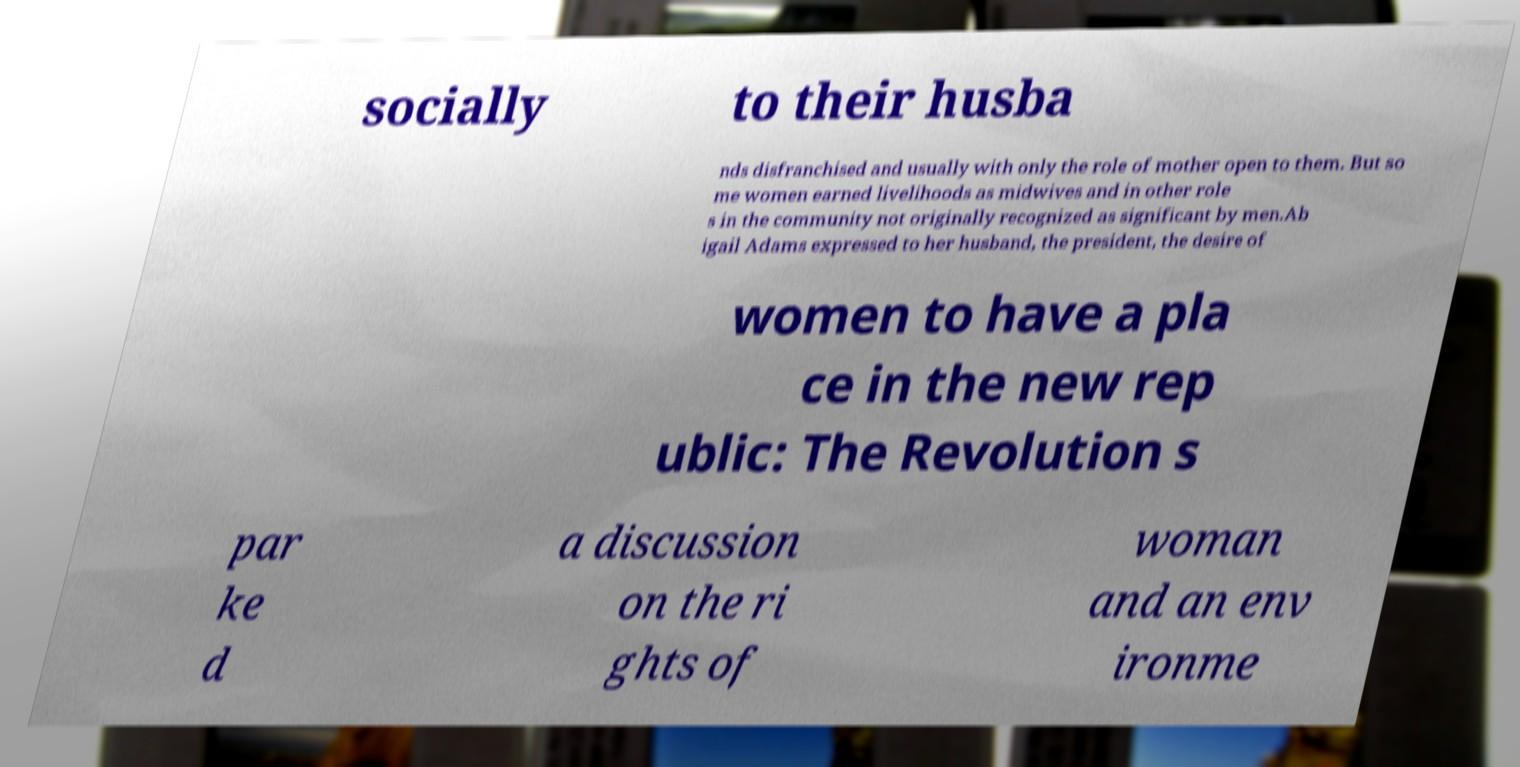Could you extract and type out the text from this image? socially to their husba nds disfranchised and usually with only the role of mother open to them. But so me women earned livelihoods as midwives and in other role s in the community not originally recognized as significant by men.Ab igail Adams expressed to her husband, the president, the desire of women to have a pla ce in the new rep ublic: The Revolution s par ke d a discussion on the ri ghts of woman and an env ironme 